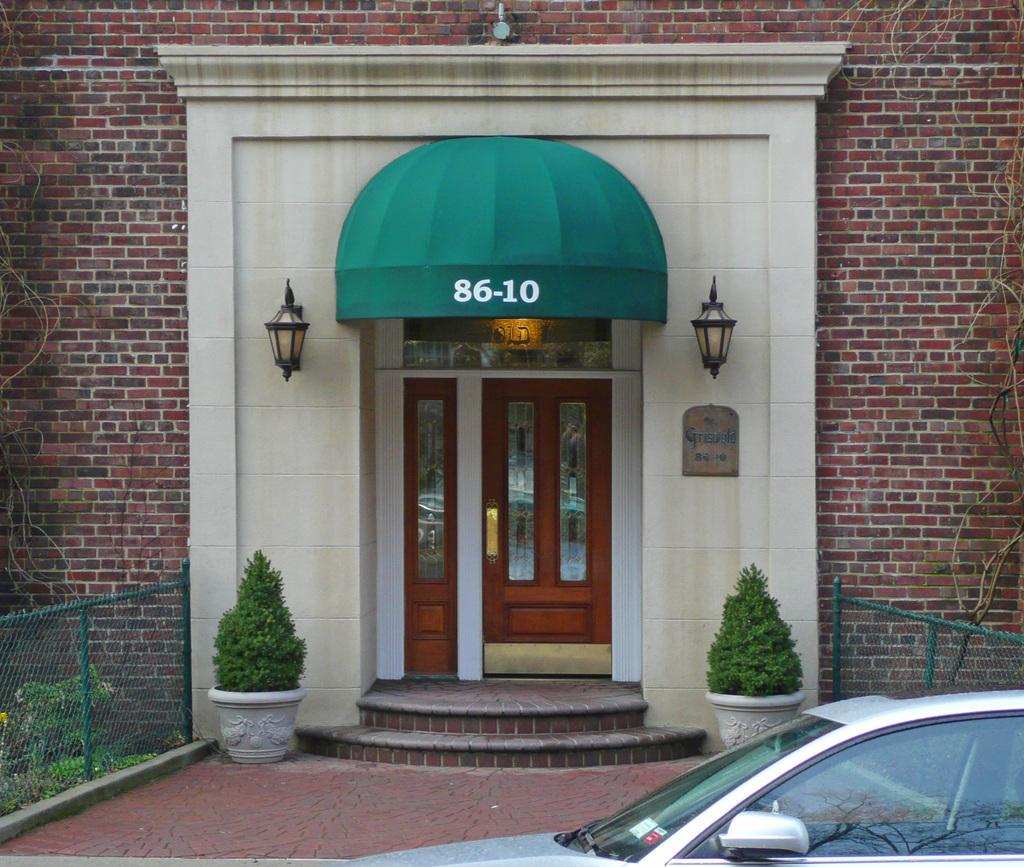What is the main structure in the center of the image? There is a building in the center of the image. What type of wall can be seen in the image? There is a brick wall in the image. Is there an entrance to the building visible? Yes, there is a door in the image. What can be seen illuminating the area in the image? There are lights in the image. Are there any plants or greenery present in the image? Yes, there are pot plants, plants, and grass in the image. What type of barrier is present in the image? There is a fence in the image. Is there a way to access different levels of the building in the image? Yes, there is a staircase in the image. What is located at the bottom of the image? There is a car at the bottom of the image. Where is the crowd gathered in the image? There is no crowd present in the image. Who is the manager of the building in the image? There is no information about a manager in the image. 